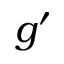Convert formula to latex. <formula><loc_0><loc_0><loc_500><loc_500>g ^ { \prime }</formula> 